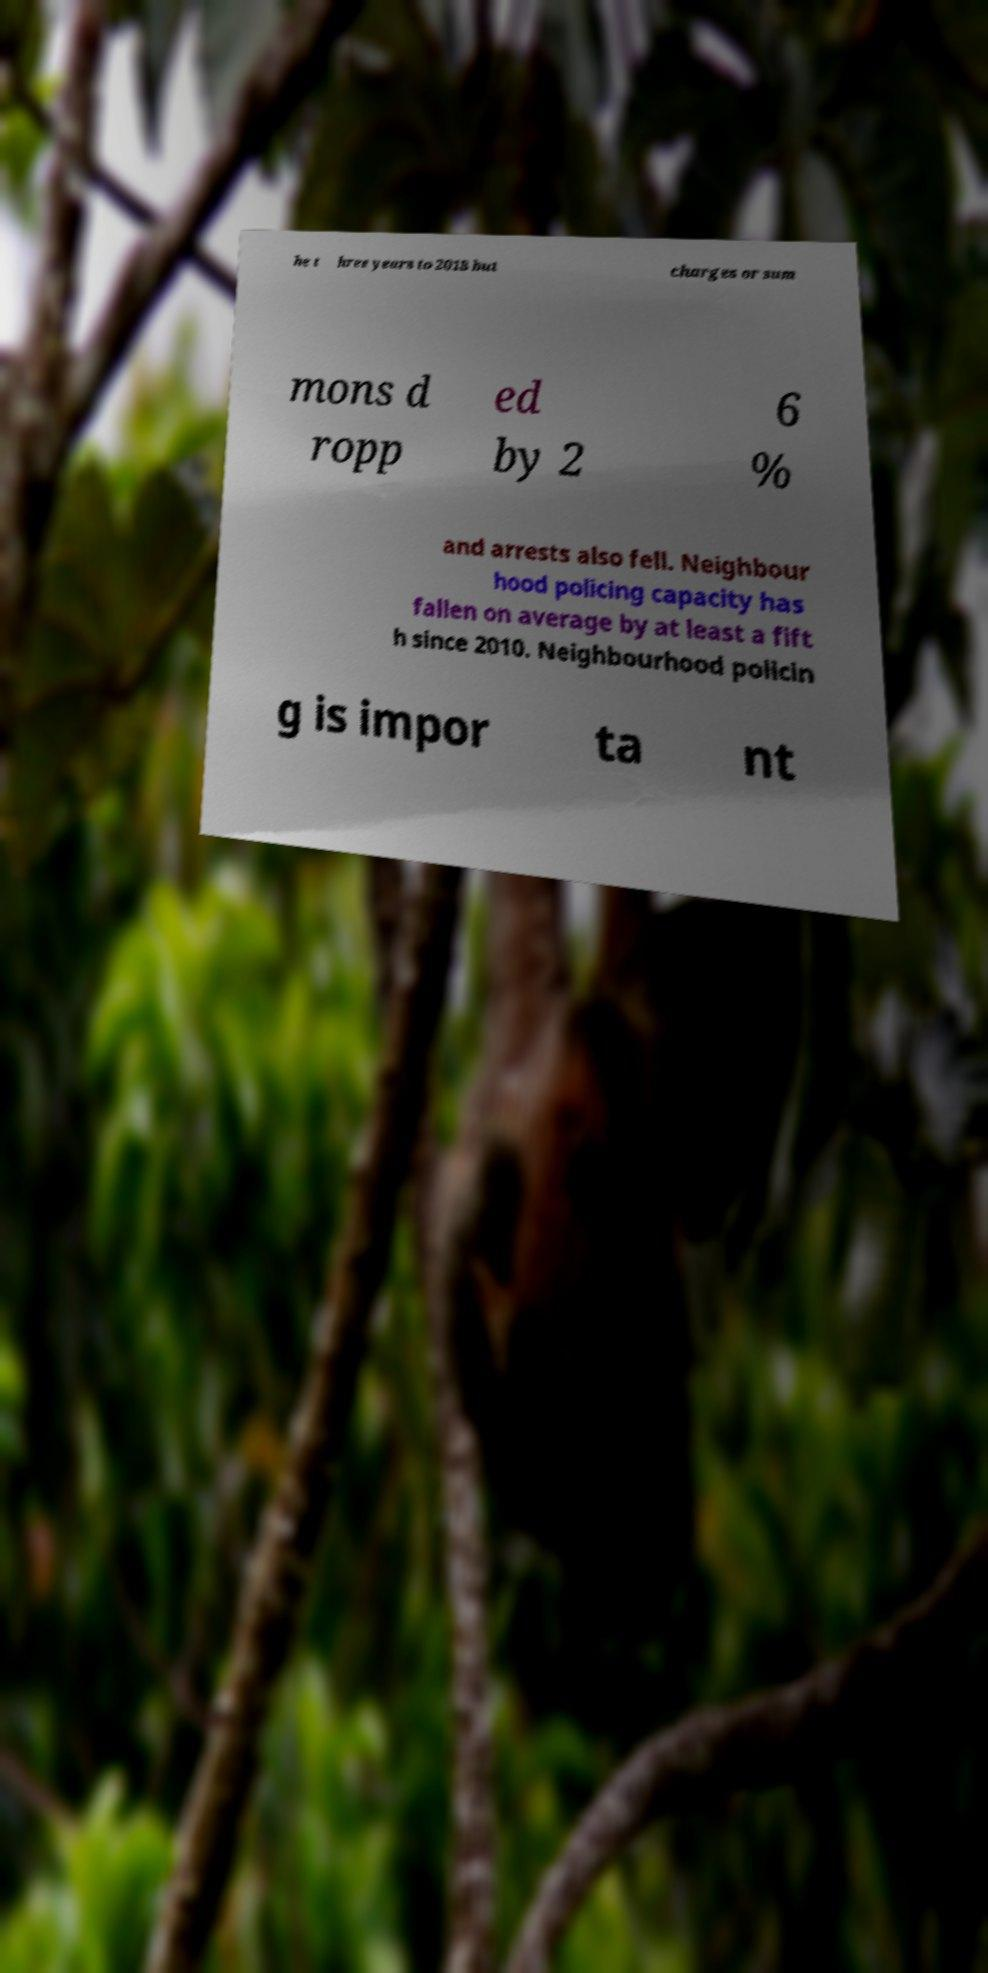I need the written content from this picture converted into text. Can you do that? he t hree years to 2018 but charges or sum mons d ropp ed by 2 6 % and arrests also fell. Neighbour hood policing capacity has fallen on average by at least a fift h since 2010. Neighbourhood policin g is impor ta nt 